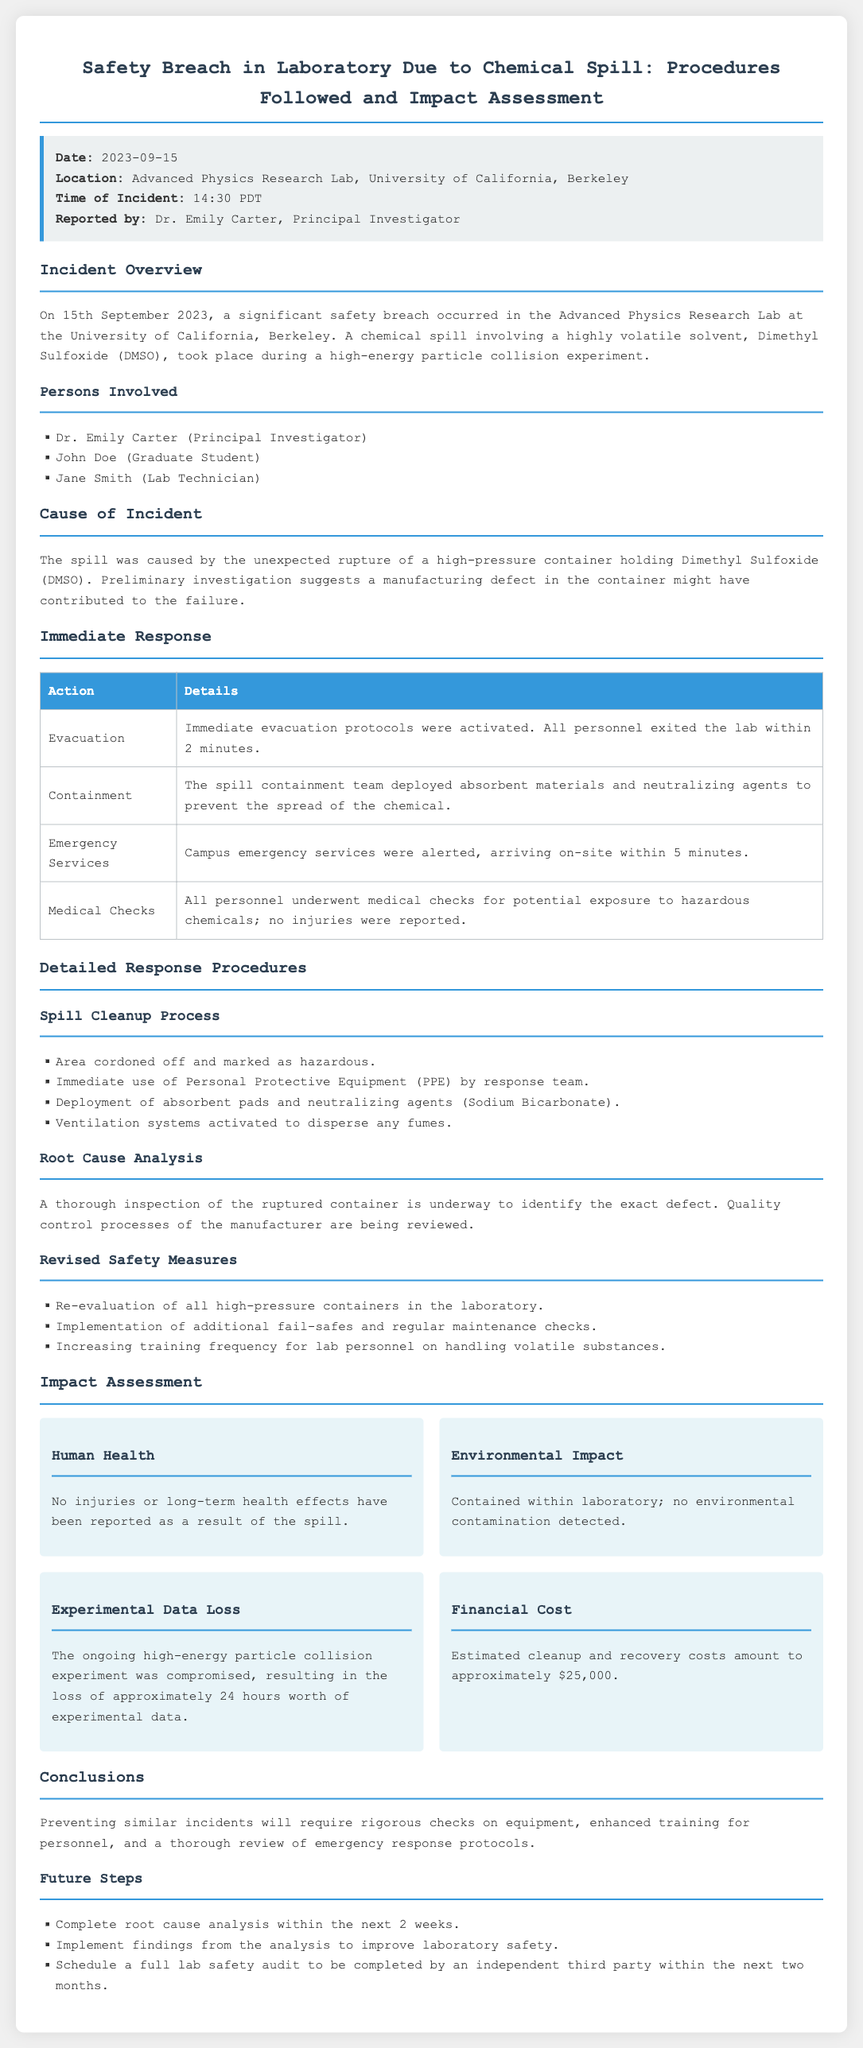What was the date of the incident? The date of the incident is specified in the document as September 15, 2023.
Answer: September 15, 2023 Who reported the incident? The document lists Dr. Emily Carter as the person who reported the incident.
Answer: Dr. Emily Carter What substance was involved in the spill? The incident report explicitly mentions the chemical involved in the spill as Dimethyl Sulfoxide (DMSO).
Answer: Dimethyl Sulfoxide (DMSO) How long did it take for personnel to evacuate? The document states that all personnel exited the lab within 2 minutes after the evacuation protocols were activated.
Answer: 2 minutes What was the estimated cleanup cost? The report provides an estimated cleanup and recovery cost of approximately $25,000.
Answer: $25,000 What immediate response action was performed first? The document indicates that the immediate evacuation was the first action taken in response to the incident.
Answer: Evacuation What are the future steps listed in the report? The report outlines several future steps including completing root cause analysis, implementing findings, and scheduling a full lab safety audit.
Answer: Complete root cause analysis within the next 2 weeks How many hours of experimental data were lost? The document states the loss of approximately 24 hours worth of experimental data due to the incident.
Answer: 24 hours What was the location of the incident? The report specifies the incident occurred in the Advanced Physics Research Lab at the University of California, Berkeley.
Answer: Advanced Physics Research Lab, University of California, Berkeley 